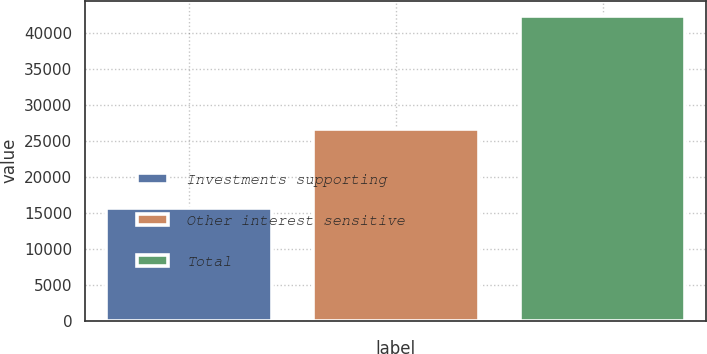Convert chart to OTSL. <chart><loc_0><loc_0><loc_500><loc_500><bar_chart><fcel>Investments supporting<fcel>Other interest sensitive<fcel>Total<nl><fcel>15724<fcel>26669<fcel>42393<nl></chart> 